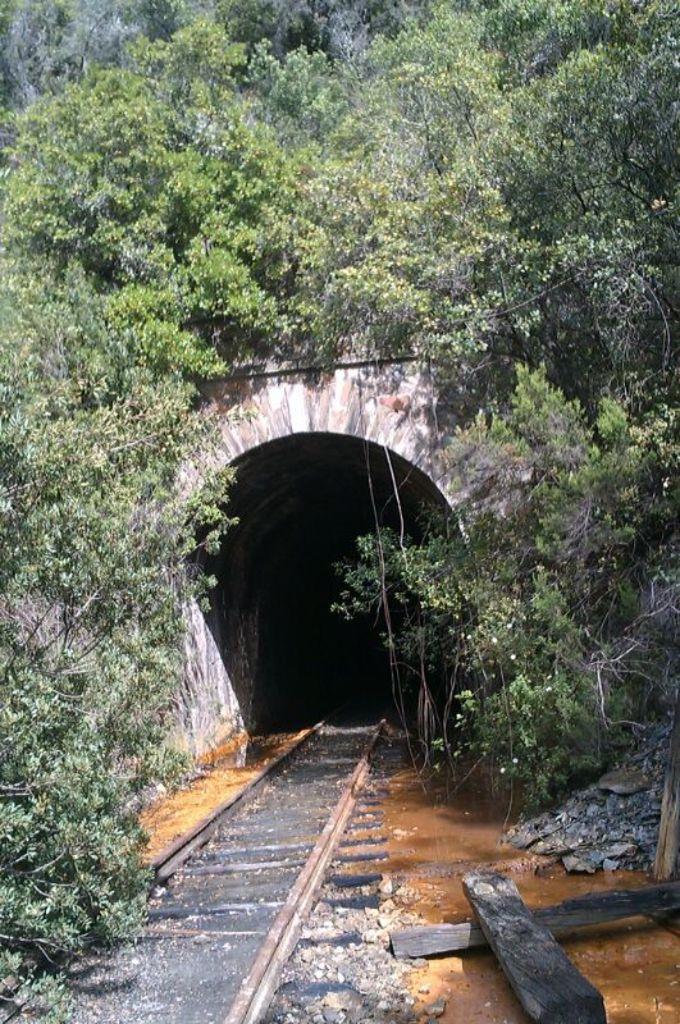How would you summarize this image in a sentence or two? In this image, we can see a track. Here we can see wooden poles, plants. In the middle of the image, we can see a tunnel, trees. 